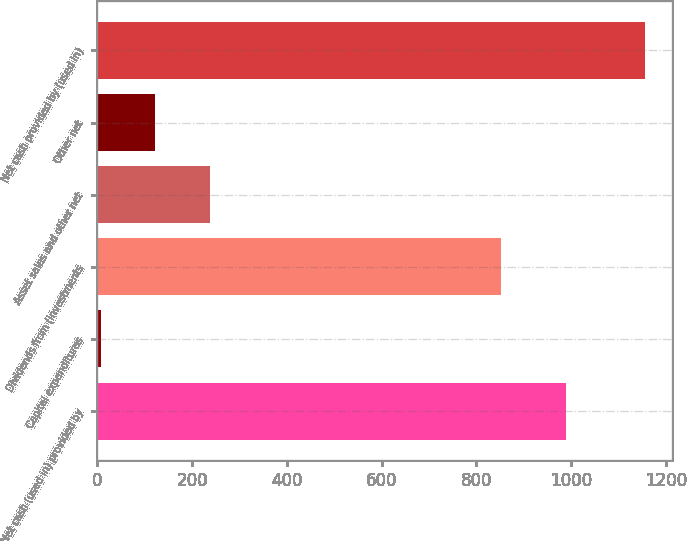<chart> <loc_0><loc_0><loc_500><loc_500><bar_chart><fcel>Net cash (used in) provided by<fcel>Capital expenditures<fcel>Dividends from (investments<fcel>Asset sales and other net<fcel>Other net<fcel>Net cash provided by (used in)<nl><fcel>988<fcel>7<fcel>852<fcel>236.6<fcel>121.8<fcel>1155<nl></chart> 